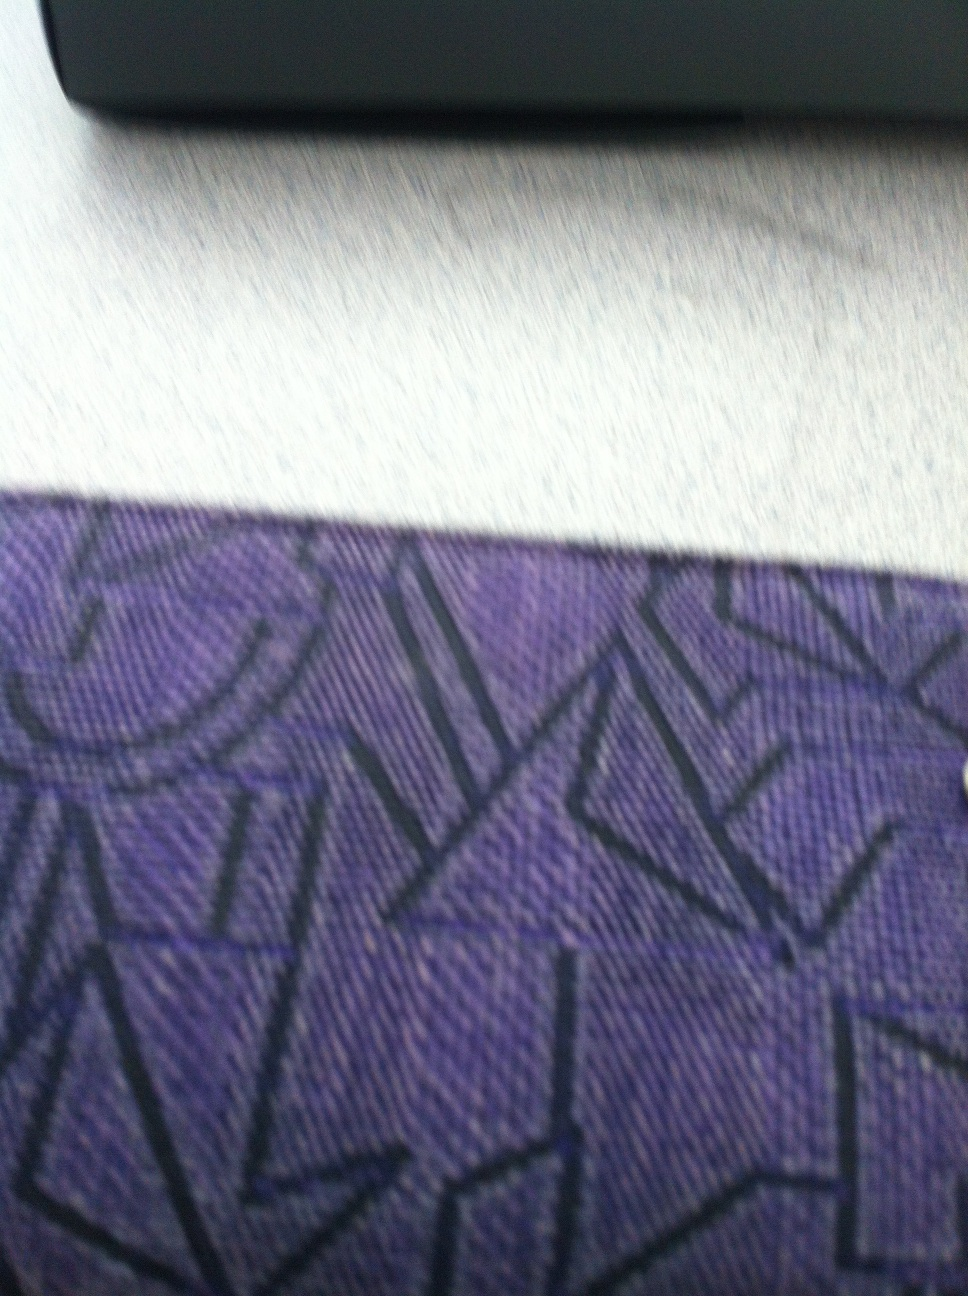Can you describe the texture and design of my wallet? Your wallet has a fabric texture with a deep purple color. The design features an intricate pattern of geometric shapes, giving it a modern and artistic appearance. 